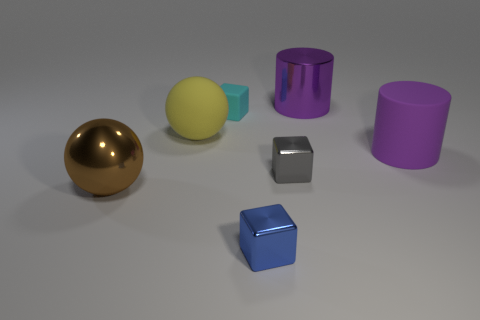Add 1 small gray metal blocks. How many objects exist? 8 Subtract all metal blocks. How many blocks are left? 1 Add 2 cylinders. How many cylinders exist? 4 Subtract 0 yellow cylinders. How many objects are left? 7 Subtract all cylinders. How many objects are left? 5 Subtract all cyan cubes. Subtract all big brown balls. How many objects are left? 5 Add 1 small cyan matte cubes. How many small cyan matte cubes are left? 2 